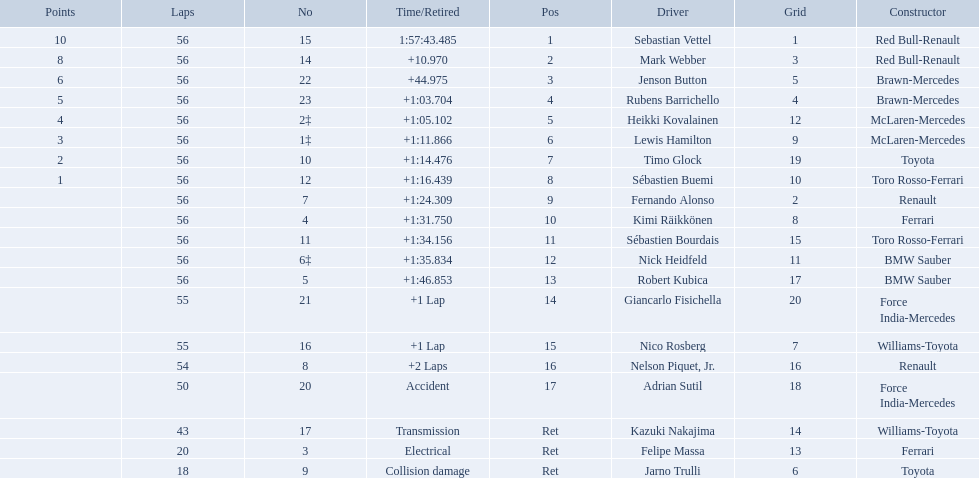Who were all the drivers? Sebastian Vettel, Mark Webber, Jenson Button, Rubens Barrichello, Heikki Kovalainen, Lewis Hamilton, Timo Glock, Sébastien Buemi, Fernando Alonso, Kimi Räikkönen, Sébastien Bourdais, Nick Heidfeld, Robert Kubica, Giancarlo Fisichella, Nico Rosberg, Nelson Piquet, Jr., Adrian Sutil, Kazuki Nakajima, Felipe Massa, Jarno Trulli. Which of these didn't have ferrari as a constructor? Sebastian Vettel, Mark Webber, Jenson Button, Rubens Barrichello, Heikki Kovalainen, Lewis Hamilton, Timo Glock, Sébastien Buemi, Fernando Alonso, Sébastien Bourdais, Nick Heidfeld, Robert Kubica, Giancarlo Fisichella, Nico Rosberg, Nelson Piquet, Jr., Adrian Sutil, Kazuki Nakajima, Jarno Trulli. Which of these was in first place? Sebastian Vettel. 